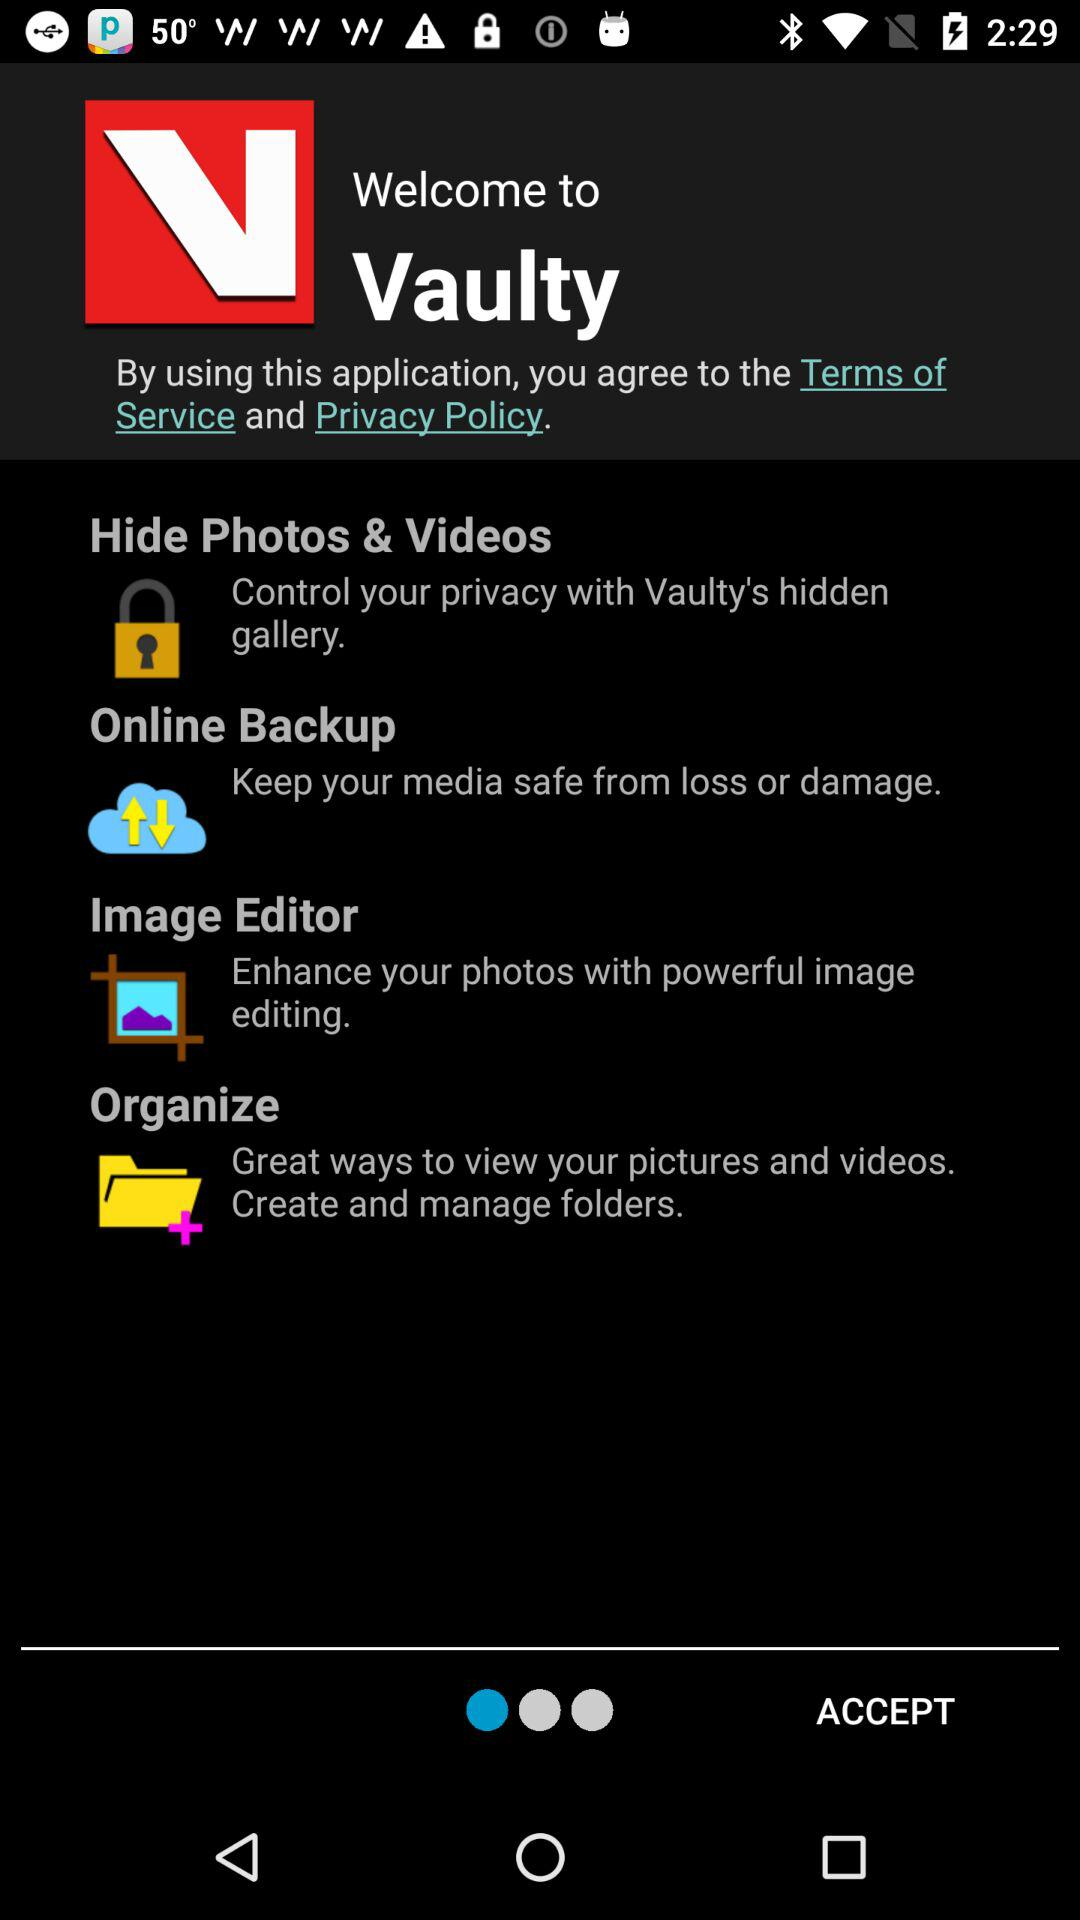How many features does Vaulty have?
Answer the question using a single word or phrase. 4 